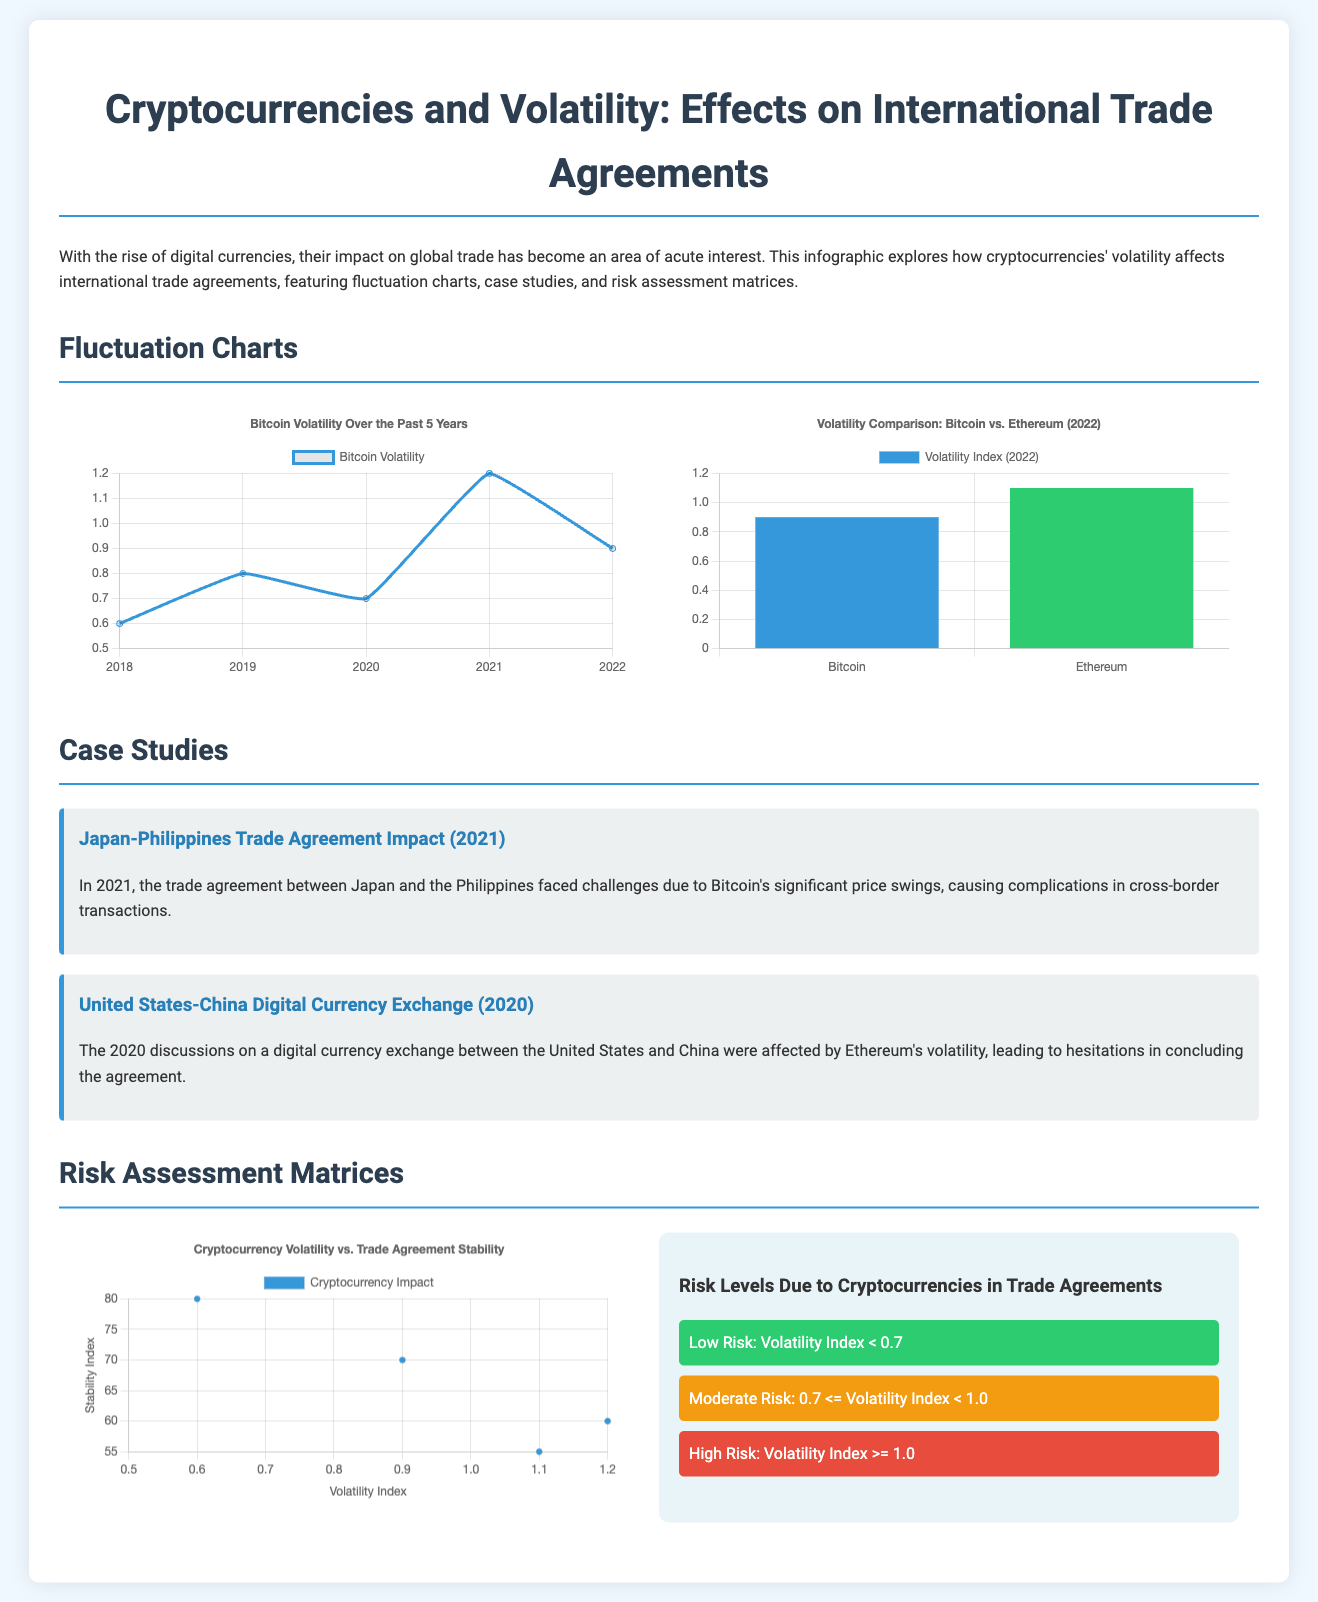What is the title of the infographic? The title of the infographic is provided at the top of the document, emphasizing the subject of study.
Answer: Cryptocurrencies and Volatility: Effects on International Trade Agreements In which year did the Japan-Philippines trade agreement face challenges? The document specifies the year in which challenges arose due to Bitcoin's price swings.
Answer: 2021 What was the volatility index for Ethereum in 2022? The document includes a comparison chart showing the volatility index of Ethereum specifically in the year 2022.
Answer: 1.1 What is the stability index for a cryptocurrency volatility index of 1.1? The scatter plot in the document shows the stability index corresponding to a given volatility index.
Answer: 55 What level of risk is indicated by a volatility index of less than 0.7? The risk assessment matrix outlines the categorization of different volatility levels concerning risk.
Answer: Low Risk What does the scatter plot depict in terms of trade agreements? The scatter plot visualizes the relationship between cryptocurrency volatility and trade agreement stability, highlighted in the document.
Answer: Cryptocurrency Volatility vs. Trade Agreement Stability How many case studies are presented in the infographic? The case studies section lists the number of studies detailing the impact of volatility on trade agreements.
Answer: 2 What color is used to represent low-risk levels in the risk matrix? The risk assessment matrix specifies color coding for different levels of risk, indicating what color represents low-risk levels.
Answer: Green 